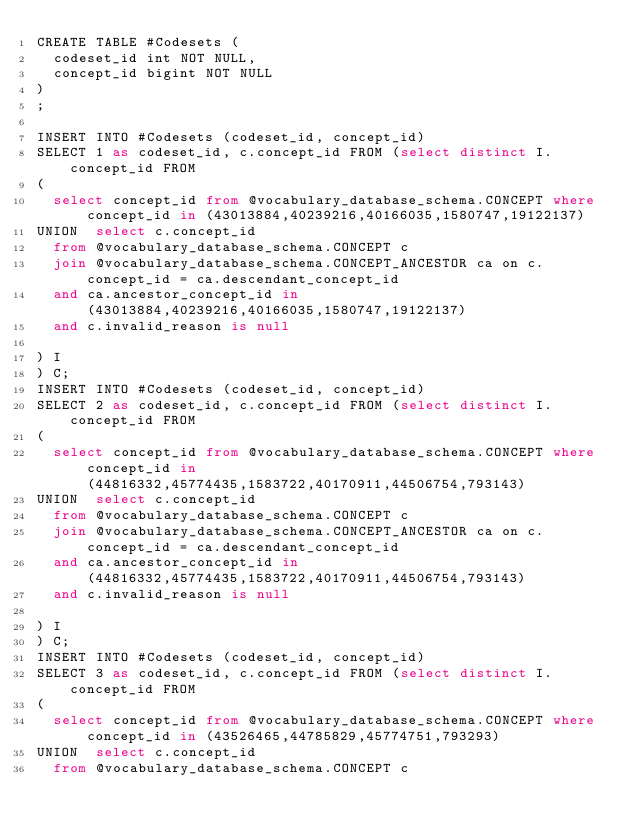<code> <loc_0><loc_0><loc_500><loc_500><_SQL_>CREATE TABLE #Codesets (
  codeset_id int NOT NULL,
  concept_id bigint NOT NULL
)
;

INSERT INTO #Codesets (codeset_id, concept_id)
SELECT 1 as codeset_id, c.concept_id FROM (select distinct I.concept_id FROM
( 
  select concept_id from @vocabulary_database_schema.CONCEPT where concept_id in (43013884,40239216,40166035,1580747,19122137)
UNION  select c.concept_id
  from @vocabulary_database_schema.CONCEPT c
  join @vocabulary_database_schema.CONCEPT_ANCESTOR ca on c.concept_id = ca.descendant_concept_id
  and ca.ancestor_concept_id in (43013884,40239216,40166035,1580747,19122137)
  and c.invalid_reason is null

) I
) C;
INSERT INTO #Codesets (codeset_id, concept_id)
SELECT 2 as codeset_id, c.concept_id FROM (select distinct I.concept_id FROM
( 
  select concept_id from @vocabulary_database_schema.CONCEPT where concept_id in (44816332,45774435,1583722,40170911,44506754,793143)
UNION  select c.concept_id
  from @vocabulary_database_schema.CONCEPT c
  join @vocabulary_database_schema.CONCEPT_ANCESTOR ca on c.concept_id = ca.descendant_concept_id
  and ca.ancestor_concept_id in (44816332,45774435,1583722,40170911,44506754,793143)
  and c.invalid_reason is null

) I
) C;
INSERT INTO #Codesets (codeset_id, concept_id)
SELECT 3 as codeset_id, c.concept_id FROM (select distinct I.concept_id FROM
( 
  select concept_id from @vocabulary_database_schema.CONCEPT where concept_id in (43526465,44785829,45774751,793293)
UNION  select c.concept_id
  from @vocabulary_database_schema.CONCEPT c</code> 